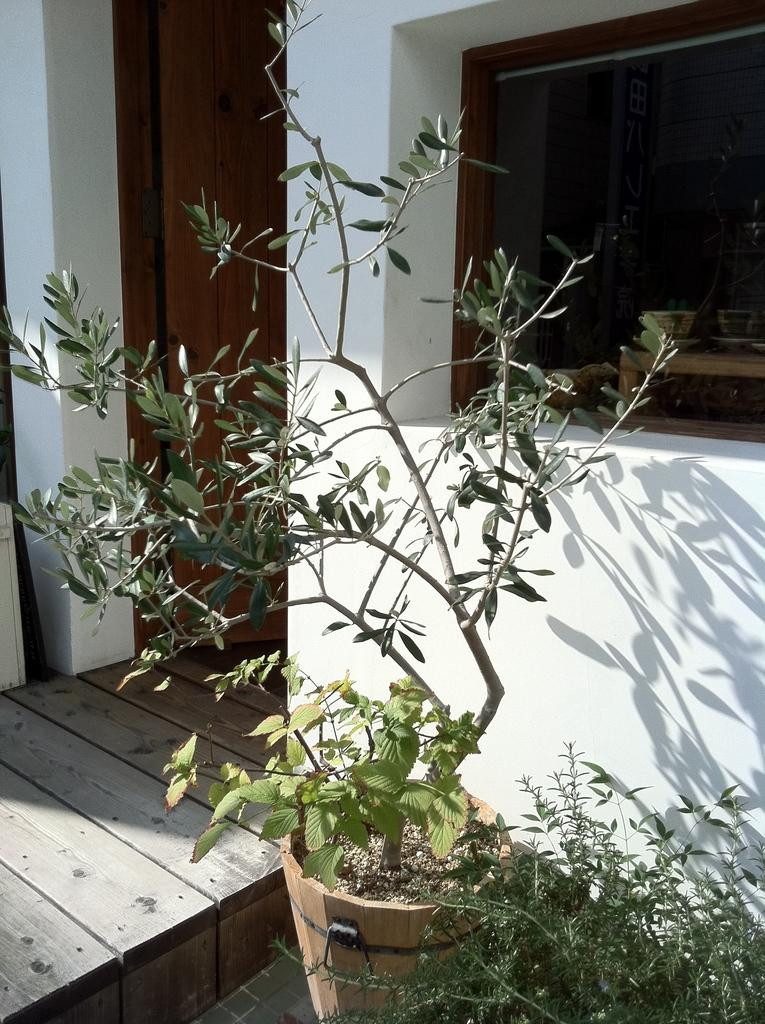What type of structure is present in the image? There is a building in the image. Can you describe an object that is attached to the wall in the image? There is a cup on the wall in the image. What type of vegetation can be seen in the foreground of the image? There are plants in the foreground of the image. What architectural features can be seen in the background of the image? There is a door and a window in the background of the image. What type of flooring is visible at the bottom of the image? There is a wooden floor visible at the bottom of the image. Can you see any ghosts interacting with the plants in the image? There are no ghosts present in the image; it only features a building, a cup on the wall, plants, a door, a window, and a wooden floor. 